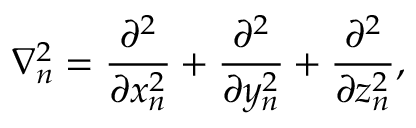Convert formula to latex. <formula><loc_0><loc_0><loc_500><loc_500>\nabla _ { n } ^ { 2 } = { \frac { \partial ^ { 2 } } { \partial x _ { n } ^ { 2 } } } + { \frac { \partial ^ { 2 } } { \partial y _ { n } ^ { 2 } } } + { \frac { \partial ^ { 2 } } { \partial z _ { n } ^ { 2 } } } ,</formula> 